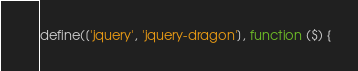<code> <loc_0><loc_0><loc_500><loc_500><_JavaScript_>define(['jquery', 'jquery-dragon'], function ($) {
</code> 